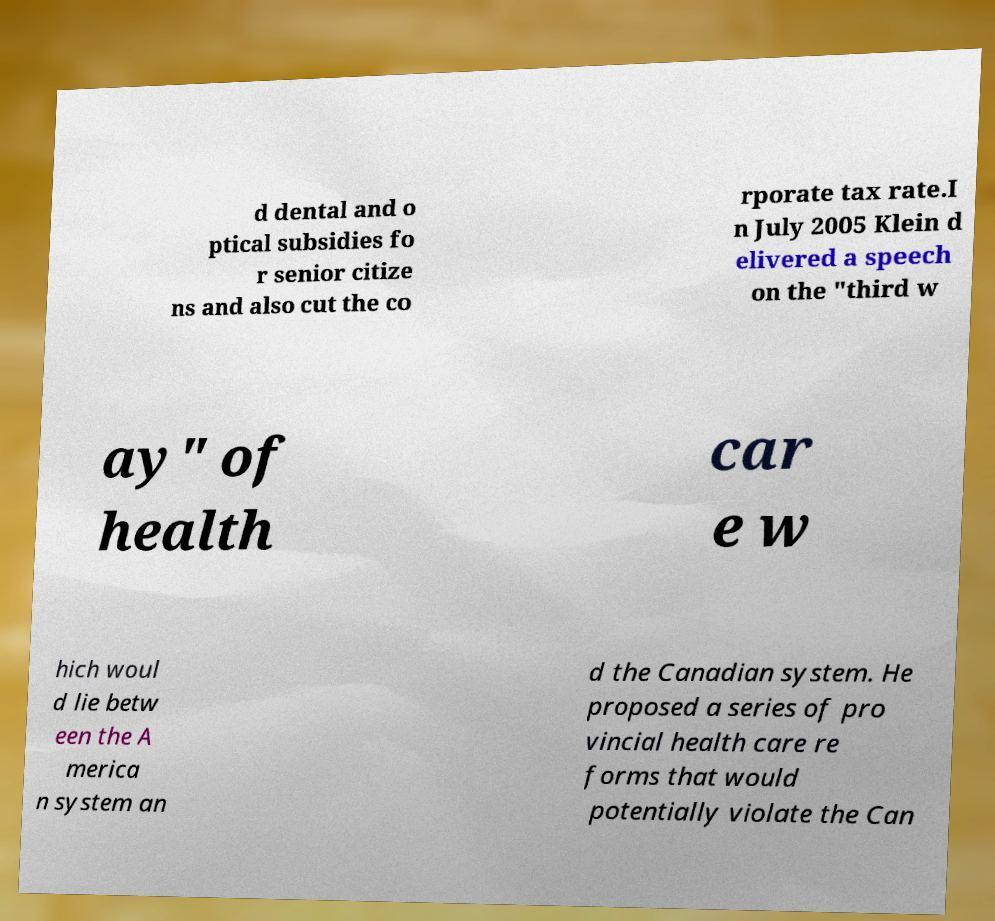Please read and relay the text visible in this image. What does it say? d dental and o ptical subsidies fo r senior citize ns and also cut the co rporate tax rate.I n July 2005 Klein d elivered a speech on the "third w ay" of health car e w hich woul d lie betw een the A merica n system an d the Canadian system. He proposed a series of pro vincial health care re forms that would potentially violate the Can 